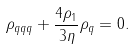<formula> <loc_0><loc_0><loc_500><loc_500>\rho _ { q q q } + \frac { 4 \rho _ { 1 } } { 3 \eta } \rho _ { q } = 0 .</formula> 